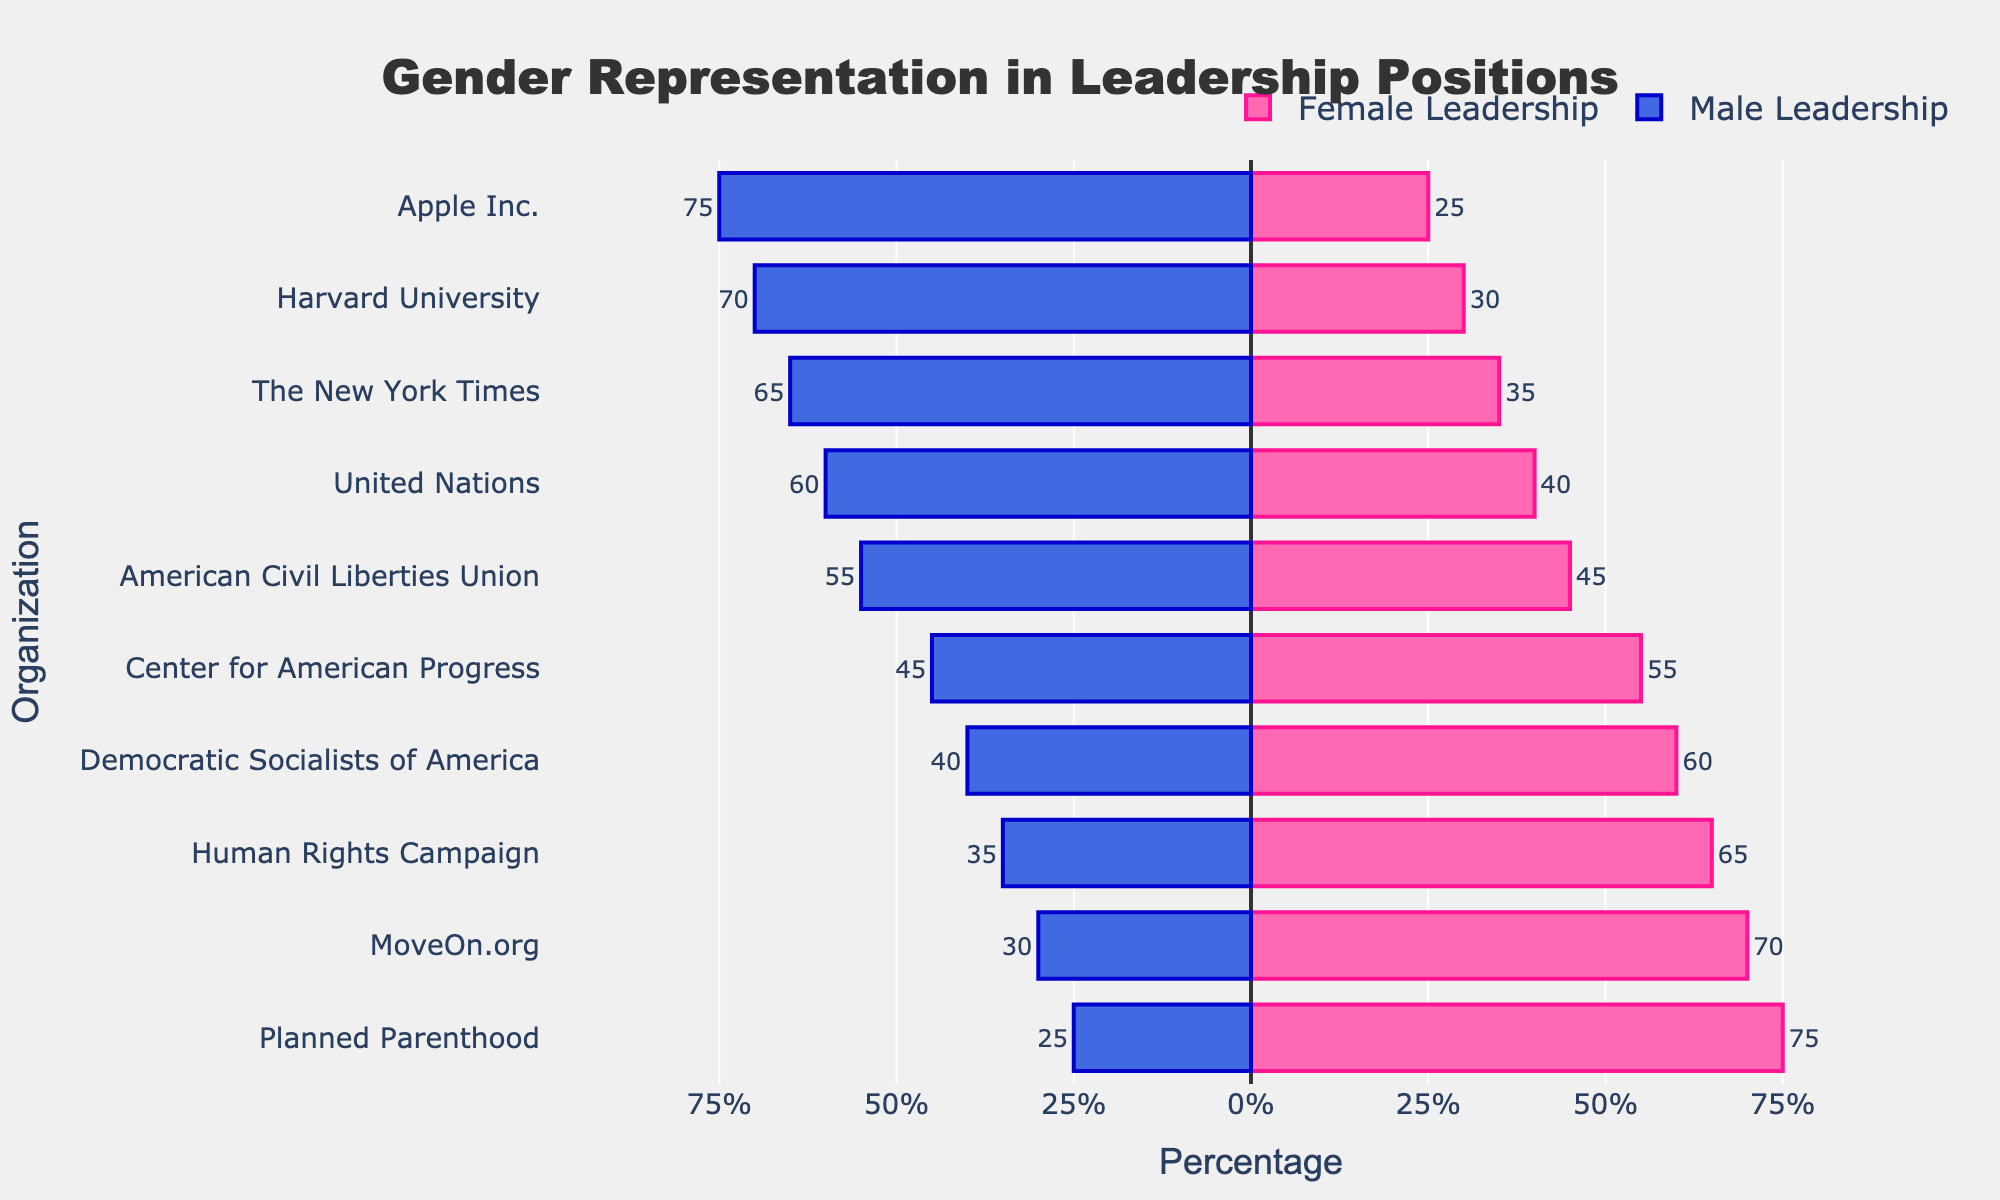What organization has the highest percentage of female leadership? The organization with the longest bar extending in the positive direction (pink bars) represents the highest percentage of female leadership. That is Planned Parenthood with 75%.
Answer: Planned Parenthood Which mainstream institution has the smallest percentage of male leadership? Look for the mainstream institution bar with the shortest length in the negative direction (blue bars). It is the American Civil Liberties Union with 55%.
Answer: American Civil Liberties Union What is the difference in female leadership percentage between Planned Parenthood and Apple Inc.? Planned Parenthood has a female leadership percentage of 75%, and Apple Inc. has a female leadership percentage of 25%. The difference is 75% - 25%.
Answer: 50% How does the gender representation in Harvard University compare to MoveOn.org? Harvard University has 30% female leadership (short pink bar extending to 30%) and 70% male leadership (long blue bar extending to 70%). In contrast, MoveOn.org has 70% female leadership (long pink bar extending to 70%) and 30% male leadership (short blue bar extending to 30%).
Answer: MoveOn.org has higher female leadership and lower male leadership Which organization has an equal or nearly equal distribution of male and female leadership? Look for bars where the lengths of the pink and blue bars are similar. The Center for American Progress has bars that appear almost equal with 55% female and 45% male.
Answer: Center for American Progress Calculate the average percentage of female leadership across all organizations. Sum the percentages of female leadership for all organizations (60% + 75% + 55% + 65% + 70% + 45% + 30% + 35% + 25% + 40%) and divide by the number of organizations (10). The sum is 500% and the average is 500% / 10.
Answer: 50% Is there any progressive organization where male leadership exceeds female leadership? Look for any progressive organizations (indicated by the pink annotation) where the blue bar extends further than the pink bar. There is no such organization; all progressive organizations have more female leadership.
Answer: No What is the combined percentage of male leadership for The New York Times and United Nations? Add the male leadership percentages of The New York Times (65%) and United Nations (60%).
Answer: 125% Which organization shows the closest to gender parity in leadership positions? Look for the organization where the pink and blue bars are closest in length. The Center for American Progress has 55% female and 45% male leadership, showing the closest parity.
Answer: Center for American Progress Comparing Planned Parenthood and the Human Rights Campaign, which organization has a higher percentage of male leadership and by how much? Human Rights Campaign has 35% male leadership, while Planned Parenthood has 25%. The difference is 35% - 25%.
Answer: Human Rights Campaign by 10% 